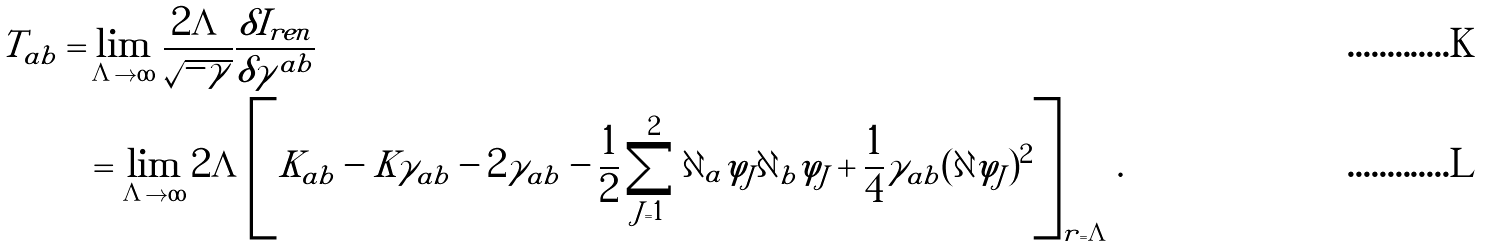Convert formula to latex. <formula><loc_0><loc_0><loc_500><loc_500>T _ { a b } = & \lim _ { \Lambda \to \infty } \frac { 2 \Lambda } { \sqrt { - \gamma } } \frac { \delta I _ { r e n } } { \delta \gamma ^ { a b } } \\ & = \lim _ { \Lambda \to \infty } 2 \Lambda \left [ K _ { a b } - K \gamma _ { a b } - 2 \gamma _ { a b } - \frac { 1 } { 2 } \sum _ { J = 1 } ^ { 2 } \partial _ { a } \varphi _ { J } \partial _ { b } \varphi _ { J } + \frac { 1 } { 4 } \gamma _ { a b } ( \partial \varphi _ { J } ) ^ { 2 } \right ] _ { r = \Lambda } .</formula> 